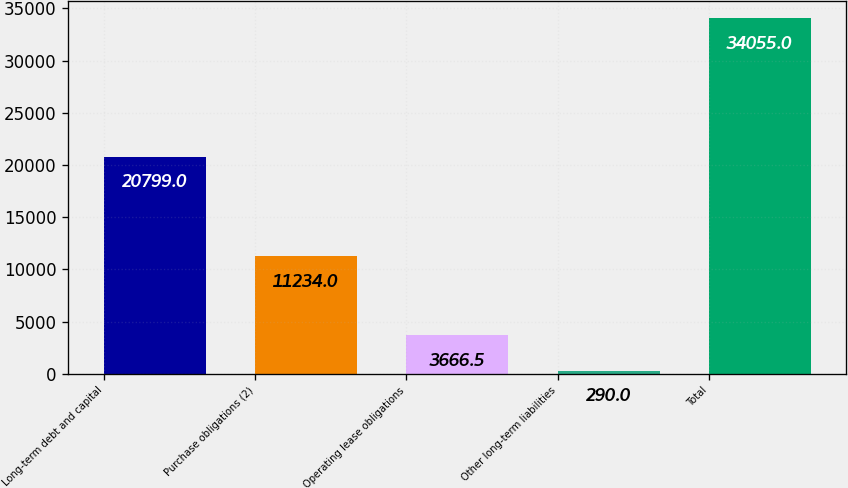Convert chart to OTSL. <chart><loc_0><loc_0><loc_500><loc_500><bar_chart><fcel>Long-term debt and capital<fcel>Purchase obligations (2)<fcel>Operating lease obligations<fcel>Other long-term liabilities<fcel>Total<nl><fcel>20799<fcel>11234<fcel>3666.5<fcel>290<fcel>34055<nl></chart> 